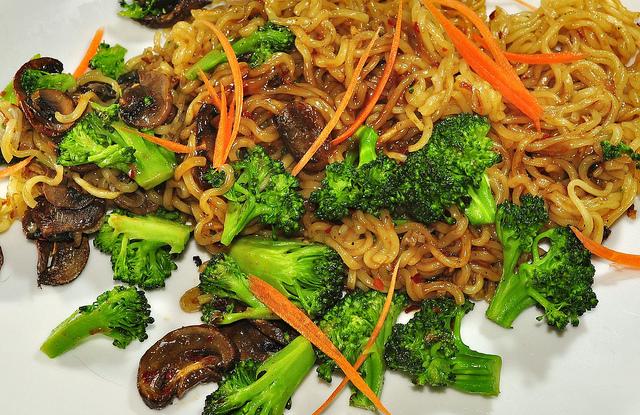Are the mushrooms sliced?
Answer briefly. Yes. Is this Chinese or Italian food?
Concise answer only. Chinese. How many piece of broccoli?
Be succinct. 15. What vegetables are in this meal?
Concise answer only. Broccoli. 